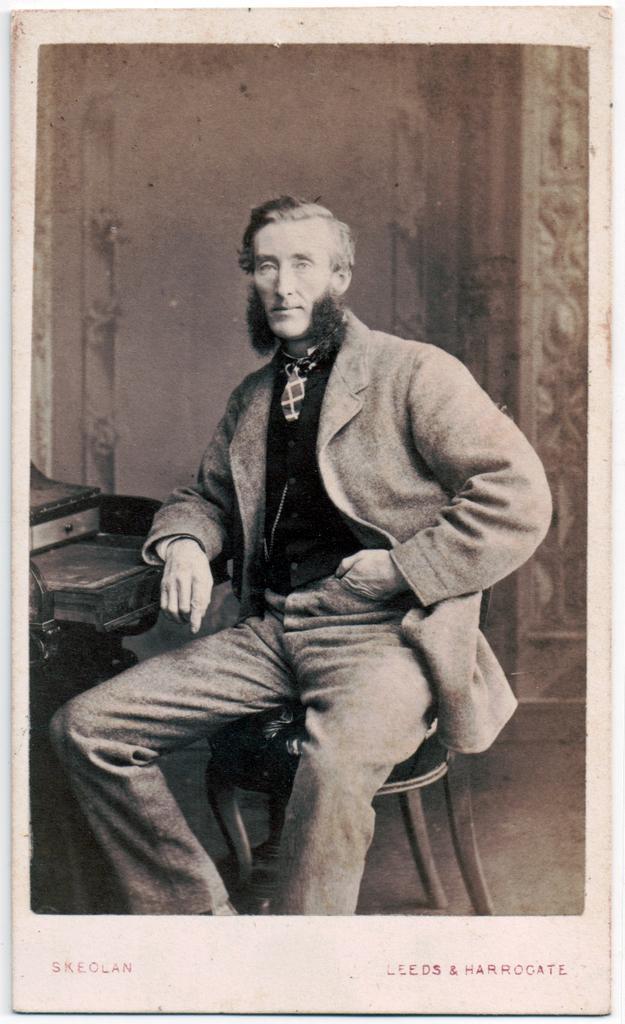Describe this image in one or two sentences. This is a black and white picture. In this picture we can see we can see a person sitting on the chair. There is some text at the bottom. We can see an object on the left side. 